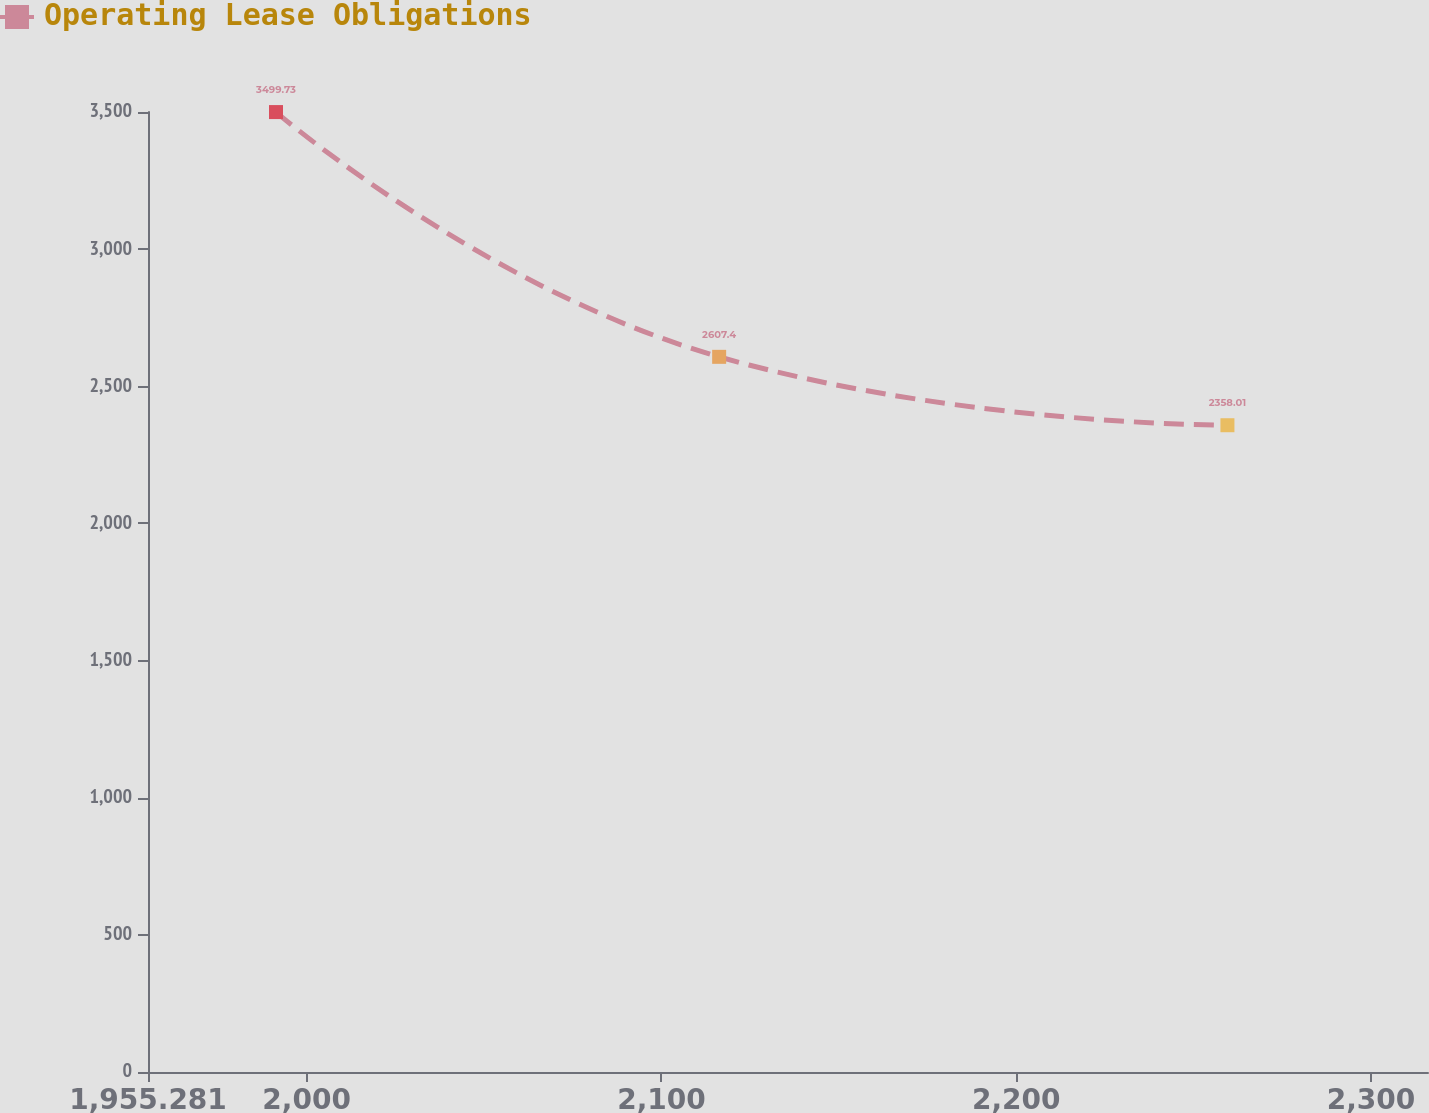<chart> <loc_0><loc_0><loc_500><loc_500><line_chart><ecel><fcel>Operating Lease Obligations<nl><fcel>1991.36<fcel>3499.73<nl><fcel>2116.27<fcel>2607.4<nl><fcel>2259.54<fcel>2358.01<nl><fcel>2318.66<fcel>2108.62<nl><fcel>2352.15<fcel>1005.79<nl></chart> 